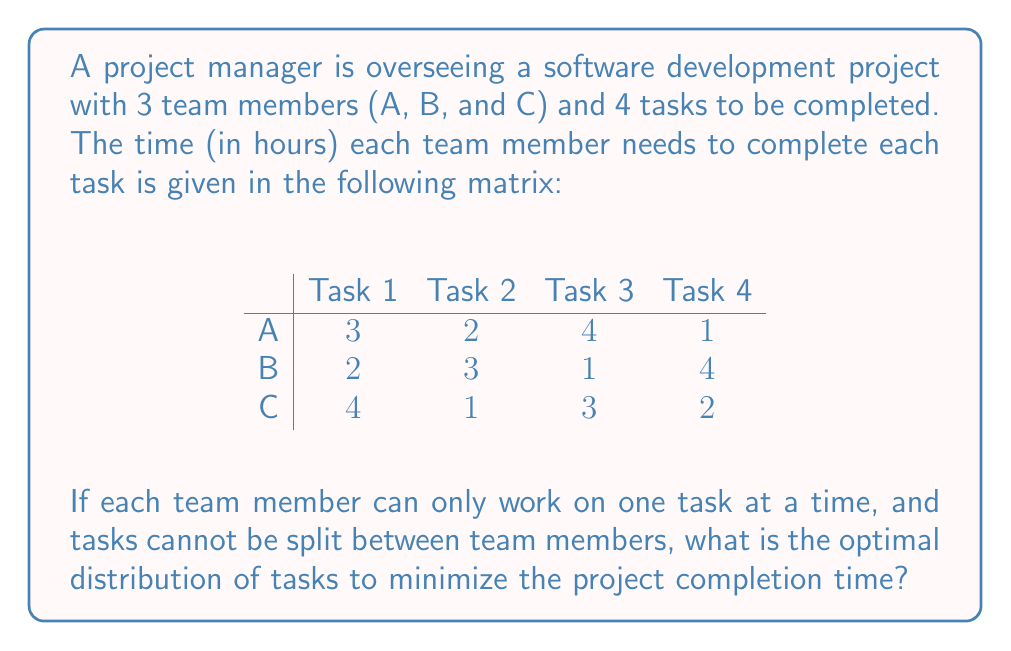Show me your answer to this math problem. To solve this problem, we need to use the Hungarian algorithm, which is an optimization algorithm for assignment problems. Here's a step-by-step approach:

1) First, we need to convert this to a maximization problem. We do this by subtracting each element from the maximum element in the matrix (4):

$$
\begin{array}{c|cccc}
 & \text{Task 1} & \text{Task 2} & \text{Task 3} & \text{Task 4} \\
\hline
\text{A} & 1 & 2 & 0 & 3 \\
\text{B} & 2 & 1 & 3 & 0 \\
\text{C} & 0 & 3 & 1 & 2 \\
\end{array}
$$

2) Now, we subtract the smallest element in each row from all elements in that row:

$$
\begin{array}{c|cccc}
 & \text{Task 1} & \text{Task 2} & \text{Task 3} & \text{Task 4} \\
\hline
\text{A} & 1 & 2 & 0 & 3 \\
\text{B} & 2 & 1 & 3 & 0 \\
\text{C} & 0 & 3 & 1 & 2 \\
\end{array}
$$

3) Next, we subtract the smallest element in each column from all elements in that column:

$$
\begin{array}{c|cccc}
 & \text{Task 1} & \text{Task 2} & \text{Task 3} & \text{Task 4} \\
\hline
\text{A} & 1 & 1 & 0 & 3 \\
\text{B} & 2 & 0 & 3 & 0 \\
\text{C} & 0 & 2 & 1 & 2 \\
\end{array}
$$

4) Now, we try to find an optimal assignment by selecting zeros, ensuring that each row and column has only one selected zero. In this case, we can select:
   A - Task 3
   B - Task 2
   C - Task 1

5) This gives us a complete assignment. We can now map this back to our original problem:
   A should do Task 3 (4 hours)
   B should do Task 2 (3 hours)
   C should do Task 1 (4 hours)

6) The project completion time is determined by the maximum time among these assignments, which is 4 hours.
Answer: A: Task 3, B: Task 2, C: Task 1; Completion time: 4 hours 